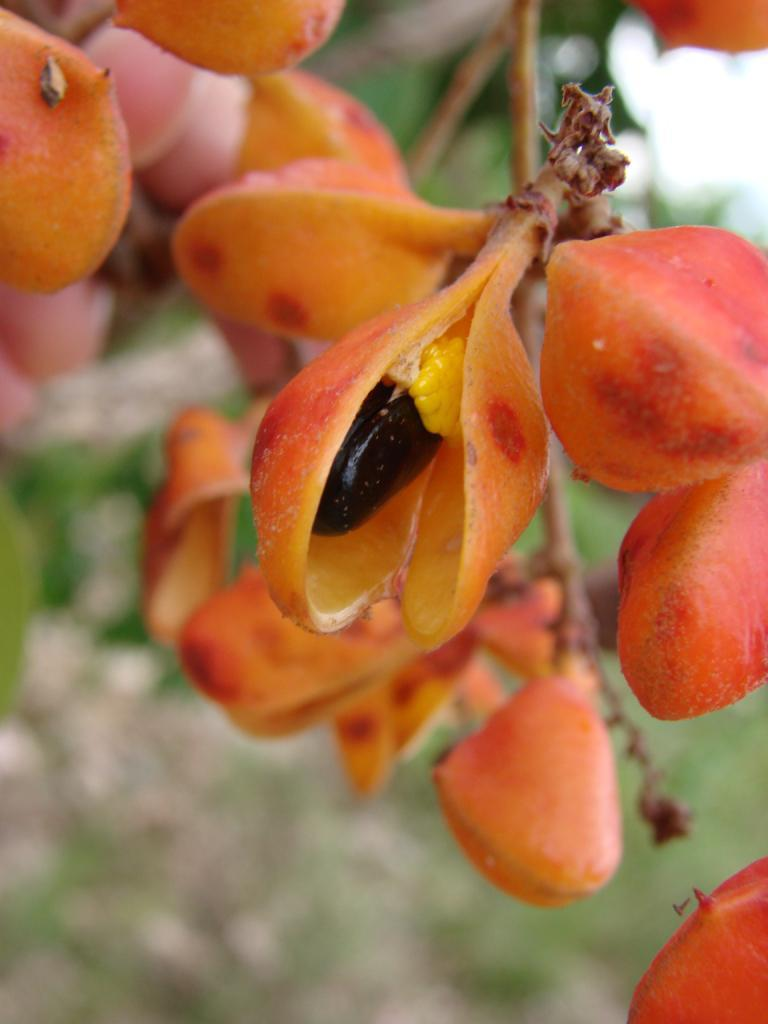What type of plant can be seen in the image? There is a flowering plant in the image. What type of brass instrument is being played by the plant in the image? There is no brass instrument present in the image, as it features a flowering plant. 